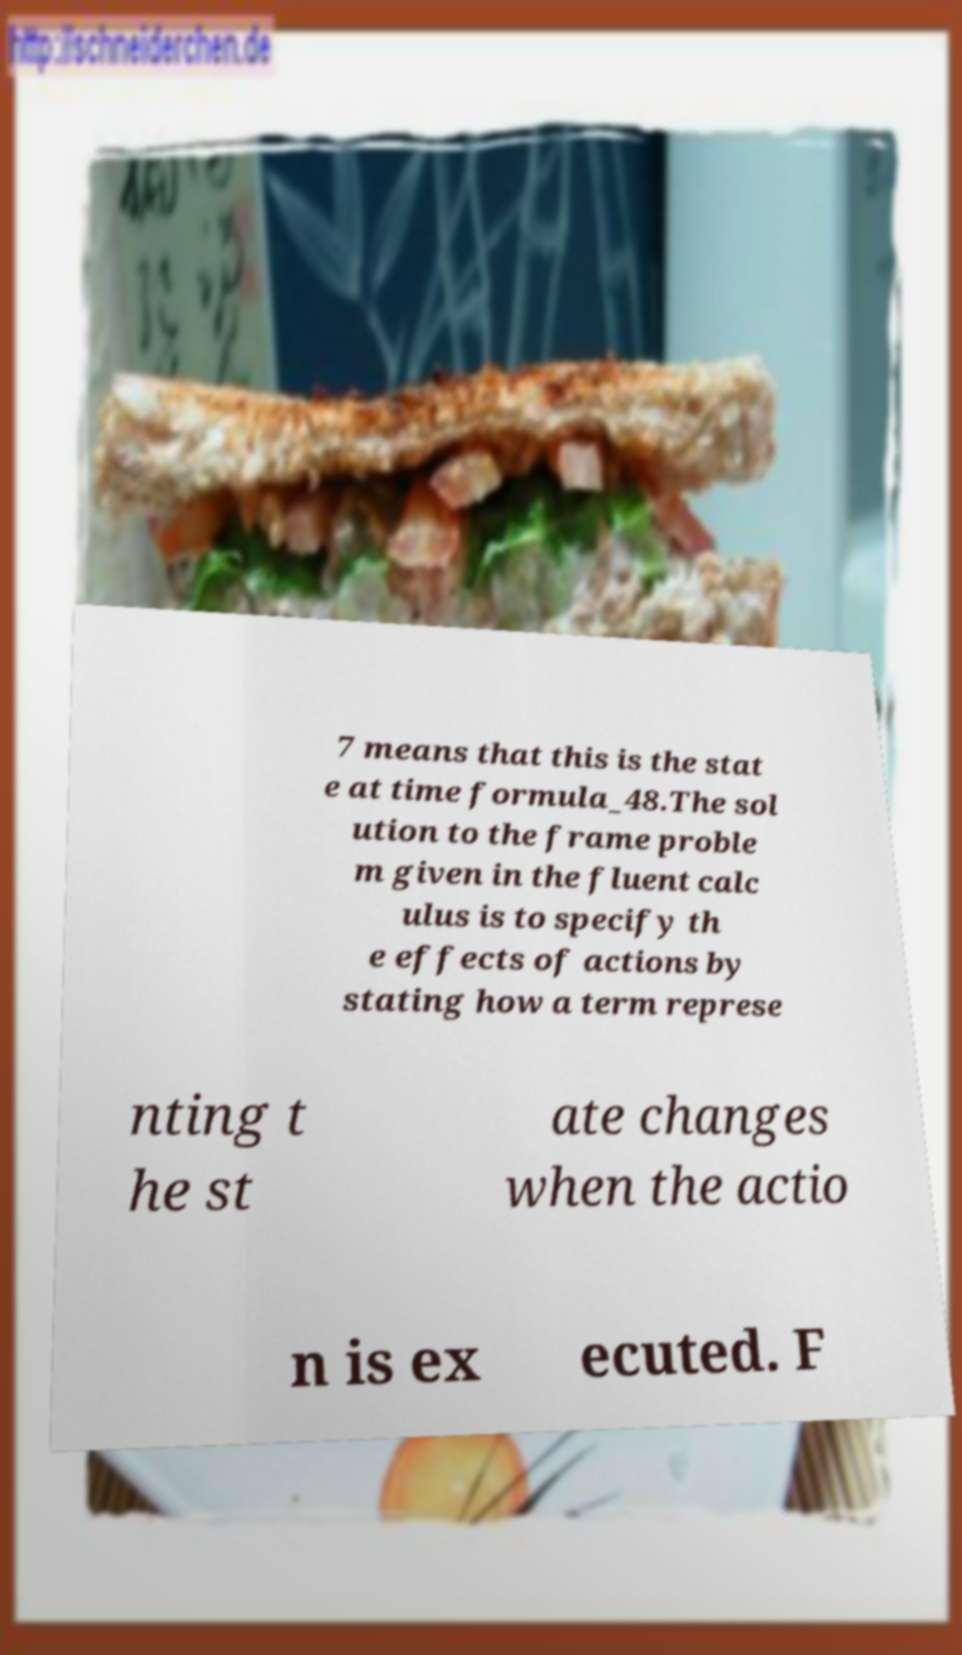Could you assist in decoding the text presented in this image and type it out clearly? 7 means that this is the stat e at time formula_48.The sol ution to the frame proble m given in the fluent calc ulus is to specify th e effects of actions by stating how a term represe nting t he st ate changes when the actio n is ex ecuted. F 